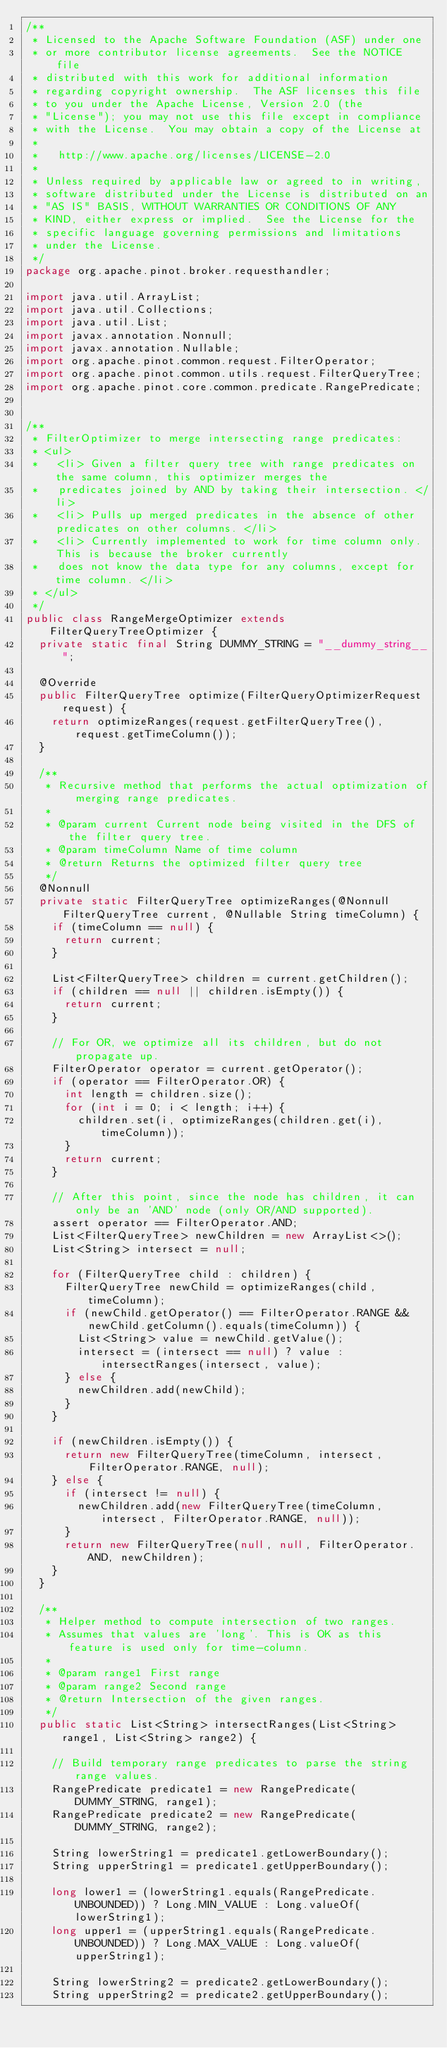Convert code to text. <code><loc_0><loc_0><loc_500><loc_500><_Java_>/**
 * Licensed to the Apache Software Foundation (ASF) under one
 * or more contributor license agreements.  See the NOTICE file
 * distributed with this work for additional information
 * regarding copyright ownership.  The ASF licenses this file
 * to you under the Apache License, Version 2.0 (the
 * "License"); you may not use this file except in compliance
 * with the License.  You may obtain a copy of the License at
 *
 *   http://www.apache.org/licenses/LICENSE-2.0
 *
 * Unless required by applicable law or agreed to in writing,
 * software distributed under the License is distributed on an
 * "AS IS" BASIS, WITHOUT WARRANTIES OR CONDITIONS OF ANY
 * KIND, either express or implied.  See the License for the
 * specific language governing permissions and limitations
 * under the License.
 */
package org.apache.pinot.broker.requesthandler;

import java.util.ArrayList;
import java.util.Collections;
import java.util.List;
import javax.annotation.Nonnull;
import javax.annotation.Nullable;
import org.apache.pinot.common.request.FilterOperator;
import org.apache.pinot.common.utils.request.FilterQueryTree;
import org.apache.pinot.core.common.predicate.RangePredicate;


/**
 * FilterOptimizer to merge intersecting range predicates:
 * <ul>
 *   <li> Given a filter query tree with range predicates on the same column, this optimizer merges the
 *   predicates joined by AND by taking their intersection. </li>
 *   <li> Pulls up merged predicates in the absence of other predicates on other columns. </li>
 *   <li> Currently implemented to work for time column only. This is because the broker currently
 *   does not know the data type for any columns, except for time column. </li>
 * </ul>
 */
public class RangeMergeOptimizer extends FilterQueryTreeOptimizer {
  private static final String DUMMY_STRING = "__dummy_string__";

  @Override
  public FilterQueryTree optimize(FilterQueryOptimizerRequest request) {
    return optimizeRanges(request.getFilterQueryTree(), request.getTimeColumn());
  }

  /**
   * Recursive method that performs the actual optimization of merging range predicates.
   *
   * @param current Current node being visited in the DFS of the filter query tree.
   * @param timeColumn Name of time column
   * @return Returns the optimized filter query tree
   */
  @Nonnull
  private static FilterQueryTree optimizeRanges(@Nonnull FilterQueryTree current, @Nullable String timeColumn) {
    if (timeColumn == null) {
      return current;
    }

    List<FilterQueryTree> children = current.getChildren();
    if (children == null || children.isEmpty()) {
      return current;
    }

    // For OR, we optimize all its children, but do not propagate up.
    FilterOperator operator = current.getOperator();
    if (operator == FilterOperator.OR) {
      int length = children.size();
      for (int i = 0; i < length; i++) {
        children.set(i, optimizeRanges(children.get(i), timeColumn));
      }
      return current;
    }

    // After this point, since the node has children, it can only be an 'AND' node (only OR/AND supported).
    assert operator == FilterOperator.AND;
    List<FilterQueryTree> newChildren = new ArrayList<>();
    List<String> intersect = null;

    for (FilterQueryTree child : children) {
      FilterQueryTree newChild = optimizeRanges(child, timeColumn);
      if (newChild.getOperator() == FilterOperator.RANGE && newChild.getColumn().equals(timeColumn)) {
        List<String> value = newChild.getValue();
        intersect = (intersect == null) ? value : intersectRanges(intersect, value);
      } else {
        newChildren.add(newChild);
      }
    }

    if (newChildren.isEmpty()) {
      return new FilterQueryTree(timeColumn, intersect, FilterOperator.RANGE, null);
    } else {
      if (intersect != null) {
        newChildren.add(new FilterQueryTree(timeColumn, intersect, FilterOperator.RANGE, null));
      }
      return new FilterQueryTree(null, null, FilterOperator.AND, newChildren);
    }
  }

  /**
   * Helper method to compute intersection of two ranges.
   * Assumes that values are 'long'. This is OK as this feature is used only for time-column.
   *
   * @param range1 First range
   * @param range2 Second range
   * @return Intersection of the given ranges.
   */
  public static List<String> intersectRanges(List<String> range1, List<String> range2) {

    // Build temporary range predicates to parse the string range values.
    RangePredicate predicate1 = new RangePredicate(DUMMY_STRING, range1);
    RangePredicate predicate2 = new RangePredicate(DUMMY_STRING, range2);

    String lowerString1 = predicate1.getLowerBoundary();
    String upperString1 = predicate1.getUpperBoundary();

    long lower1 = (lowerString1.equals(RangePredicate.UNBOUNDED)) ? Long.MIN_VALUE : Long.valueOf(lowerString1);
    long upper1 = (upperString1.equals(RangePredicate.UNBOUNDED)) ? Long.MAX_VALUE : Long.valueOf(upperString1);

    String lowerString2 = predicate2.getLowerBoundary();
    String upperString2 = predicate2.getUpperBoundary();
</code> 